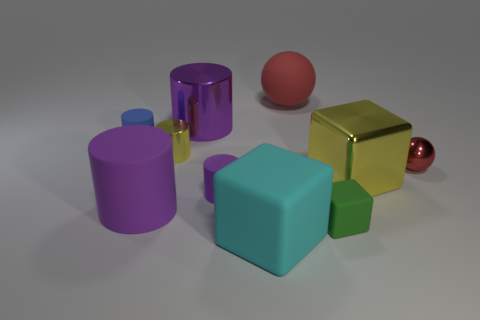Subtract all purple cylinders. How many were subtracted if there are1purple cylinders left? 2 Subtract all brown balls. How many purple cylinders are left? 3 Subtract 2 cylinders. How many cylinders are left? 3 Subtract all blue cylinders. How many cylinders are left? 4 Subtract all big purple metal cylinders. How many cylinders are left? 4 Subtract all red cylinders. Subtract all purple cubes. How many cylinders are left? 5 Subtract all cubes. How many objects are left? 7 Add 7 matte spheres. How many matte spheres are left? 8 Add 6 tiny purple cylinders. How many tiny purple cylinders exist? 7 Subtract 0 purple spheres. How many objects are left? 10 